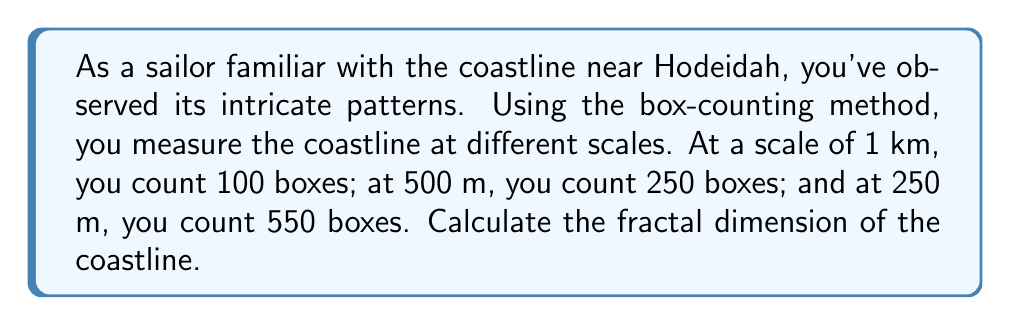Solve this math problem. To calculate the fractal dimension using the box-counting method, we'll follow these steps:

1) The box-counting dimension $D$ is given by the formula:

   $$D = \lim_{\epsilon \to 0} \frac{\log N(\epsilon)}{\log(1/\epsilon)}$$

   where $N(\epsilon)$ is the number of boxes of side length $\epsilon$ needed to cover the object.

2) We have three data points:
   - Scale 1: $\epsilon_1 = 1$ km, $N(\epsilon_1) = 100$
   - Scale 2: $\epsilon_2 = 0.5$ km, $N(\epsilon_2) = 250$
   - Scale 3: $\epsilon_3 = 0.25$ km, $N(\epsilon_3) = 550$

3) We'll use the slope of the log-log plot to estimate $D$. For any two scales:

   $$D \approx \frac{\log(N_2/N_1)}{\log(\epsilon_1/\epsilon_2)}$$

4) Let's calculate $D$ using scales 1 and 3:

   $$D \approx \frac{\log(550/100)}{\log(1/0.25)} = \frac{\log(5.5)}{\log(4)}$$

5) Calculating this:

   $$D \approx \frac{1.7047}{1.3863} \approx 1.2297$$

6) We can verify using the other scale combinations:
   - Scales 1 and 2: $D \approx 1.3219$
   - Scales 2 and 3: $D \approx 1.1375$

7) The average of these three estimates is:

   $$D_{avg} = \frac{1.2297 + 1.3219 + 1.1375}{3} \approx 1.2297$$

Thus, the estimated fractal dimension of the coastline is approximately 1.2297.
Answer: 1.2297 